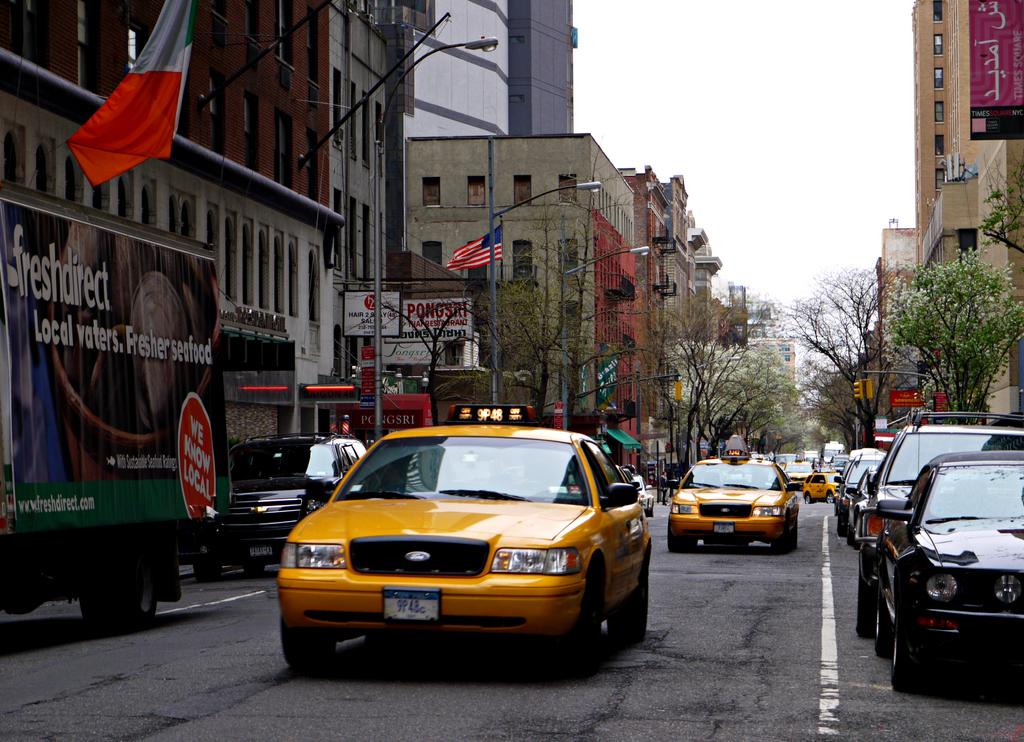What company owns the truck on the left?
Provide a succinct answer. Freshdirect. What kind of waters does freshdirect advertise?
Your answer should be compact. Local. 